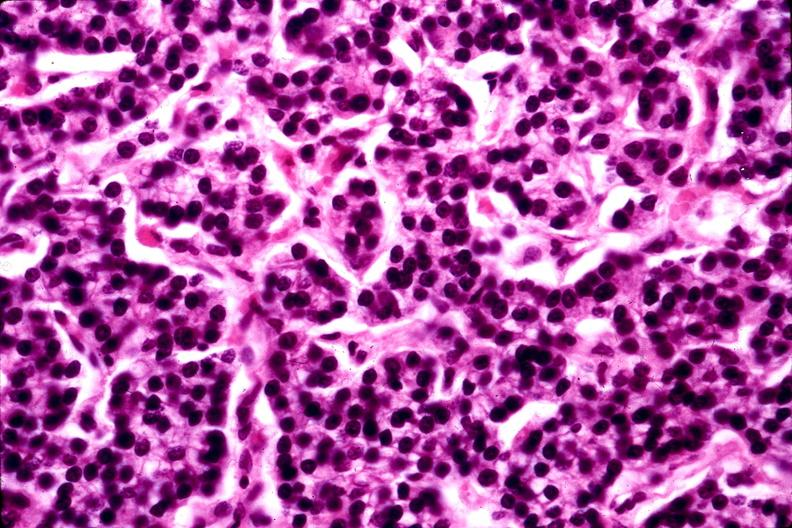what is present?
Answer the question using a single word or phrase. Endocrine 